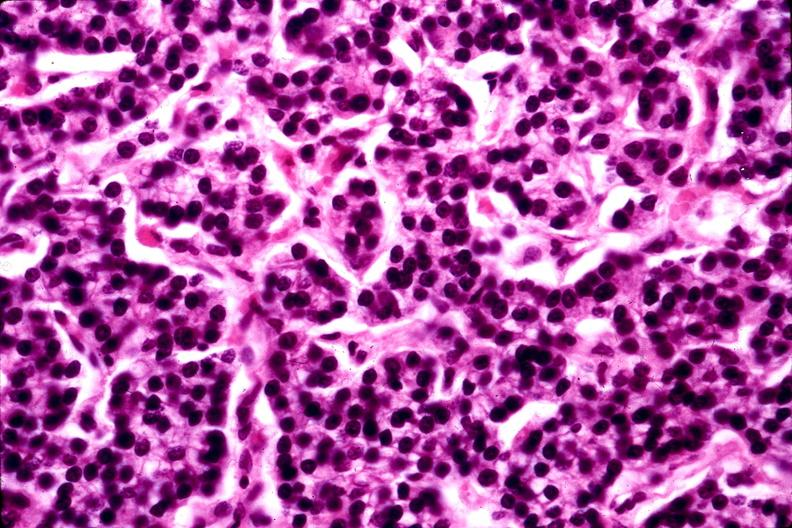what is present?
Answer the question using a single word or phrase. Endocrine 